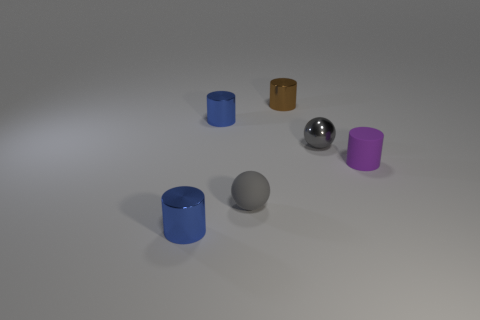Are there an equal number of small matte spheres that are to the right of the brown cylinder and small cylinders that are right of the tiny purple object?
Ensure brevity in your answer.  Yes. Does the small gray ball in front of the rubber cylinder have the same material as the purple cylinder behind the small gray rubber thing?
Ensure brevity in your answer.  Yes. What is the brown cylinder made of?
Offer a very short reply. Metal. How many other objects are there of the same color as the matte ball?
Keep it short and to the point. 1. Do the tiny shiny ball and the tiny matte ball have the same color?
Ensure brevity in your answer.  Yes. How many things are there?
Ensure brevity in your answer.  6. The sphere in front of the gray shiny sphere that is behind the purple rubber cylinder is made of what material?
Offer a terse response. Rubber. There is a purple cylinder that is the same size as the brown metal thing; what is it made of?
Keep it short and to the point. Rubber. There is a object in front of the gray rubber thing; does it have the same shape as the purple thing?
Your answer should be compact. Yes. What number of objects are tiny gray metallic balls or small blue objects that are behind the tiny rubber sphere?
Ensure brevity in your answer.  2. 